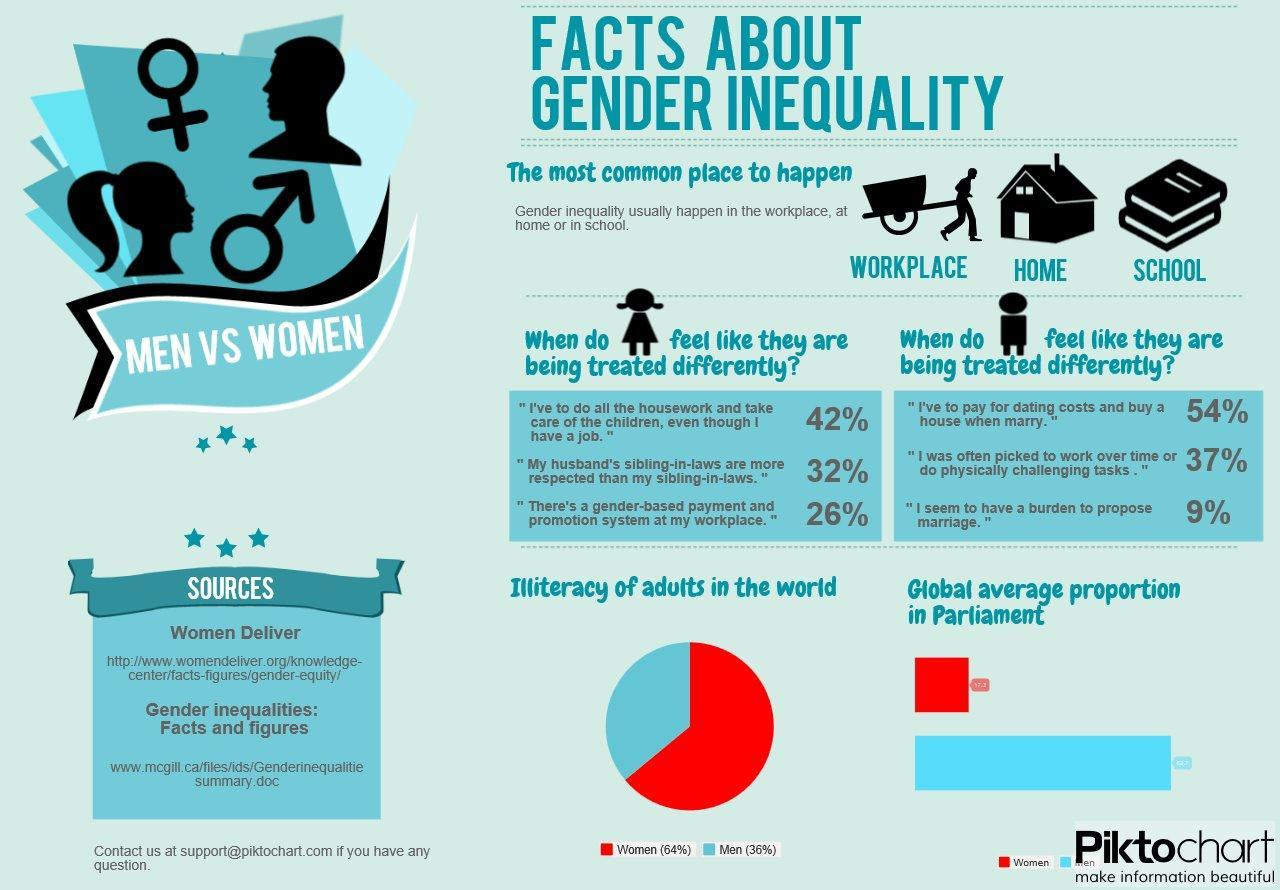what is the illiteracy rates of females in the world
Answer the question with a short phrase. 64% what is the illiteracy rate of males in the world 35% how many % of women do not feel that there's gender-based payment and promotion at workplace 74 9% of which gender seem to have a burden to propose marriage men WHich are the common places where gender inequality happen in the workplace, at home or in school 54% of which gender think that they have to pay for dating costs and buy a house when marry men in the global average proportion in parliament, females are shown in which colour, red or blue red 